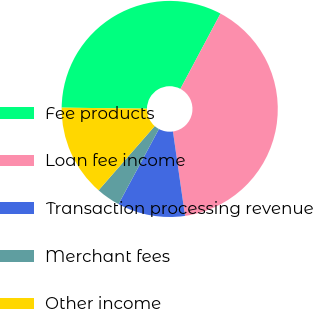Convert chart to OTSL. <chart><loc_0><loc_0><loc_500><loc_500><pie_chart><fcel>Fee products<fcel>Loan fee income<fcel>Transaction processing revenue<fcel>Merchant fees<fcel>Other income<nl><fcel>32.59%<fcel>39.95%<fcel>10.12%<fcel>3.58%<fcel>13.76%<nl></chart> 